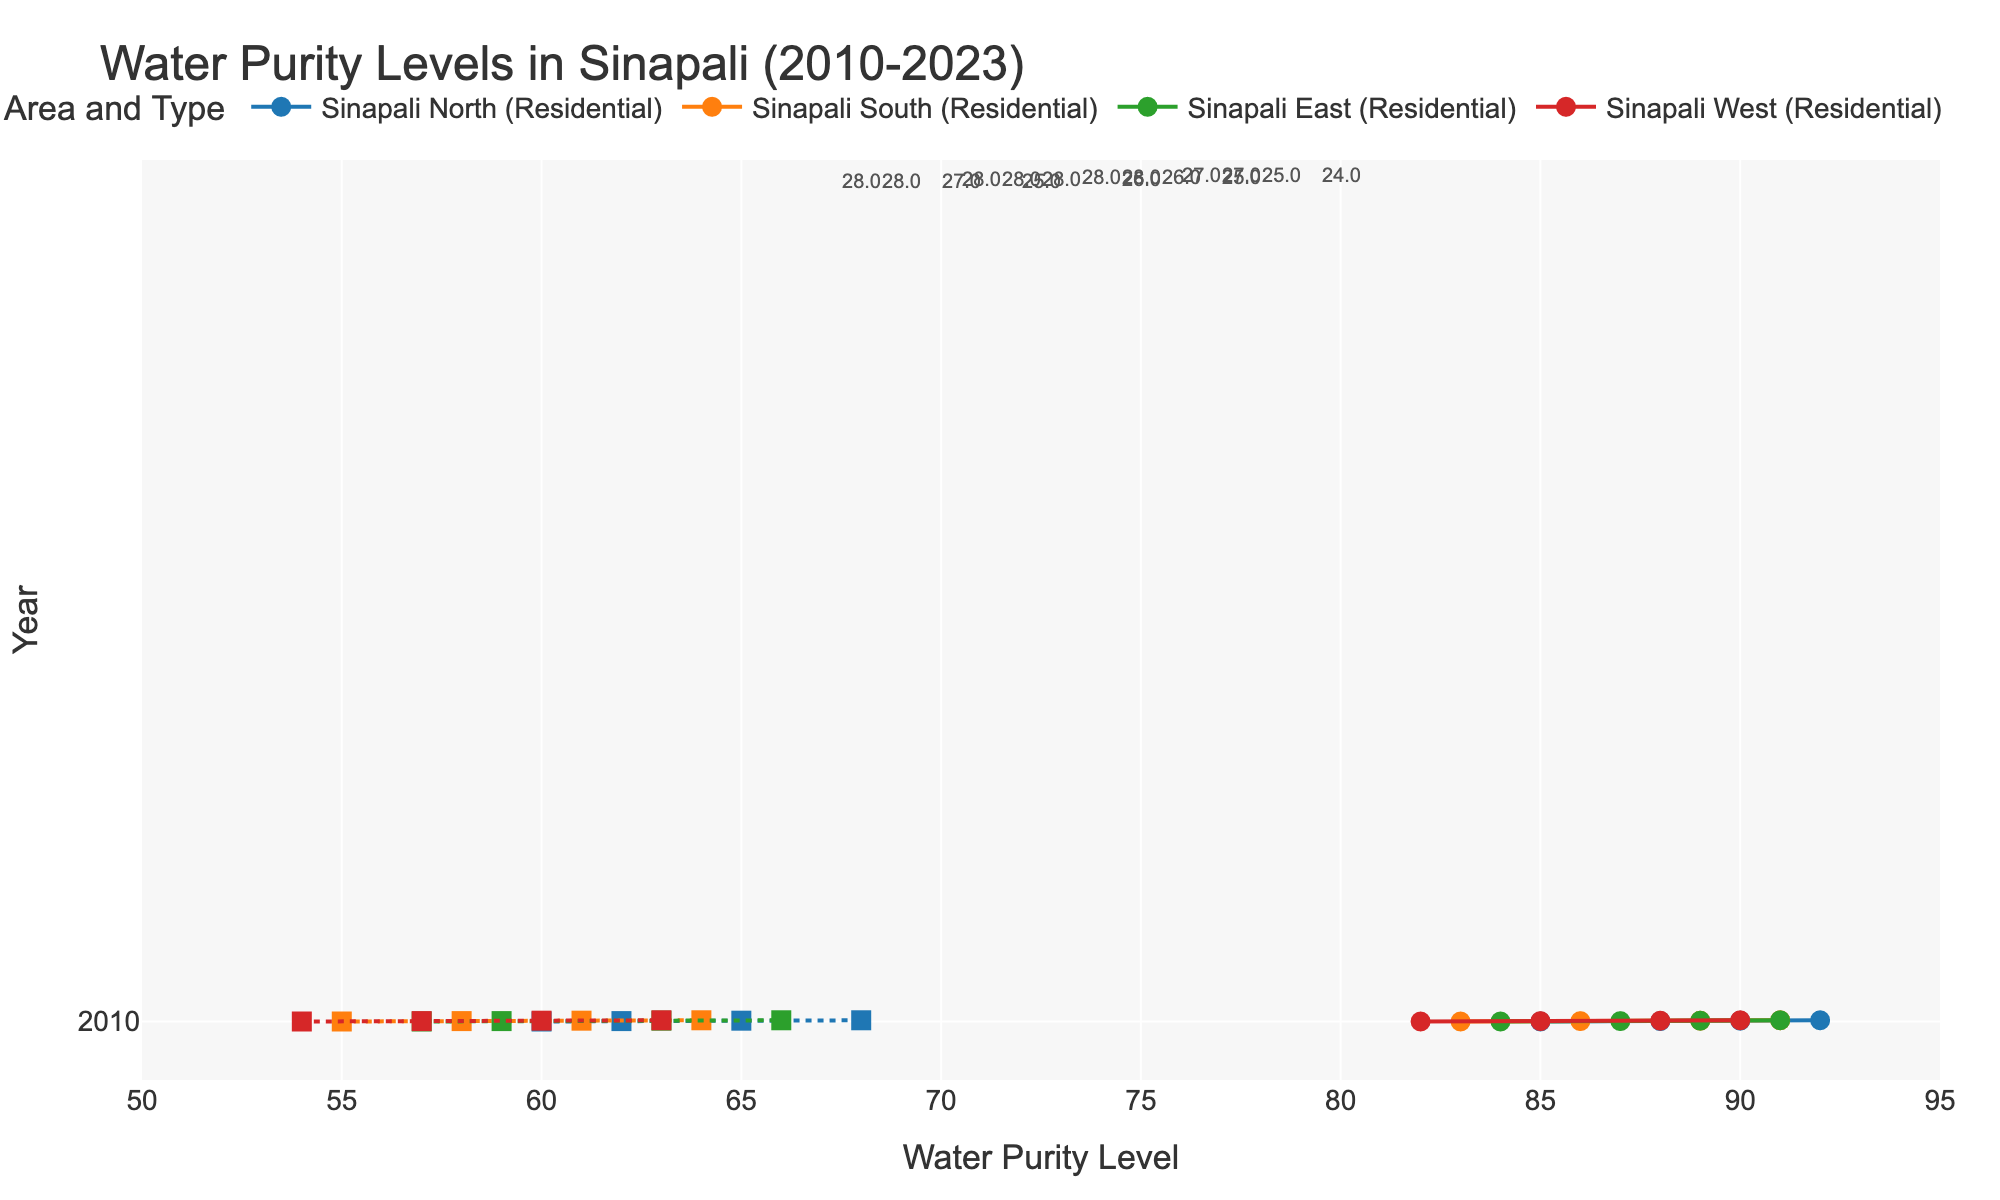What is the title of the figure? The title is located at the top of the figure and is meant to give an overview of what the plot is displaying.
Answer: Water Purity Levels in Sinapali (2010-2023) How many years are displayed in the plot? The years are listed on the y-axis of the figure. Count the number of unique years present.
Answer: 4 What are the water purity levels for Sinapali North in 2020 for both residential and industrial areas? Locate Sinapali North in 2020 on the y-axis, and then look for the corresponding points on the x-axis to get these values.
Answer: Residential: 90, Industrial: 65 Between which years did the residential water purity level in Sinapali South have the highest absolute increase? Compare the increments between consecutive years for residential water purity levels in Sinapali South and find the largest one.
Answer: 2010 to 2015 Which area had the lowest industrial water purity level in 2010? Look at the 2010 row and compare the industrial water purity levels in all areas to find the minima.
Answer: Sinapali West What is the average water purity level for residential areas across Sinapali East in 2023? As there is only one data point per area for each year, the average is simply the value at Sinapali East in 2023.
Answer: 91 How much did the water purity level for industrial areas in Sinapali North increase between 2010 and 2023? Subtract the industrial water purity level of 2010 from that of 2023 for Sinapali North.
Answer: 8 Which area experienced the smallest difference in water purity levels between residential and industrial areas in 2023? For each area in 2023, calculate the difference between residential and industrial water purity levels, and find the one with the smallest value.
Answer: Sinapali West How does the trend of water purity levels in Sinapali North compare between residential and industrial areas over the observed period? Observe the direction and magnitude of change for water purity levels in both residential and industrial areas in Sinapali North and compare their general behaviors over time.
Answer: Both increase, but residential increases more What is the median water purity level for industrial areas in 2015 across all areas? List the water purity levels for industrial areas across all areas in 2015 and determine the middle value.
Answer: 58 